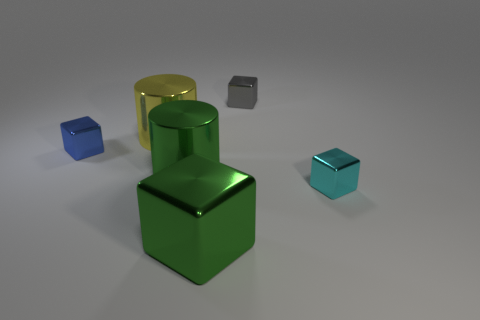Add 3 yellow things. How many objects exist? 9 Subtract all blocks. How many objects are left? 2 Subtract 1 yellow cylinders. How many objects are left? 5 Subtract all purple matte objects. Subtract all tiny cyan objects. How many objects are left? 5 Add 1 small blue metallic cubes. How many small blue metallic cubes are left? 2 Add 6 small blue shiny blocks. How many small blue shiny blocks exist? 7 